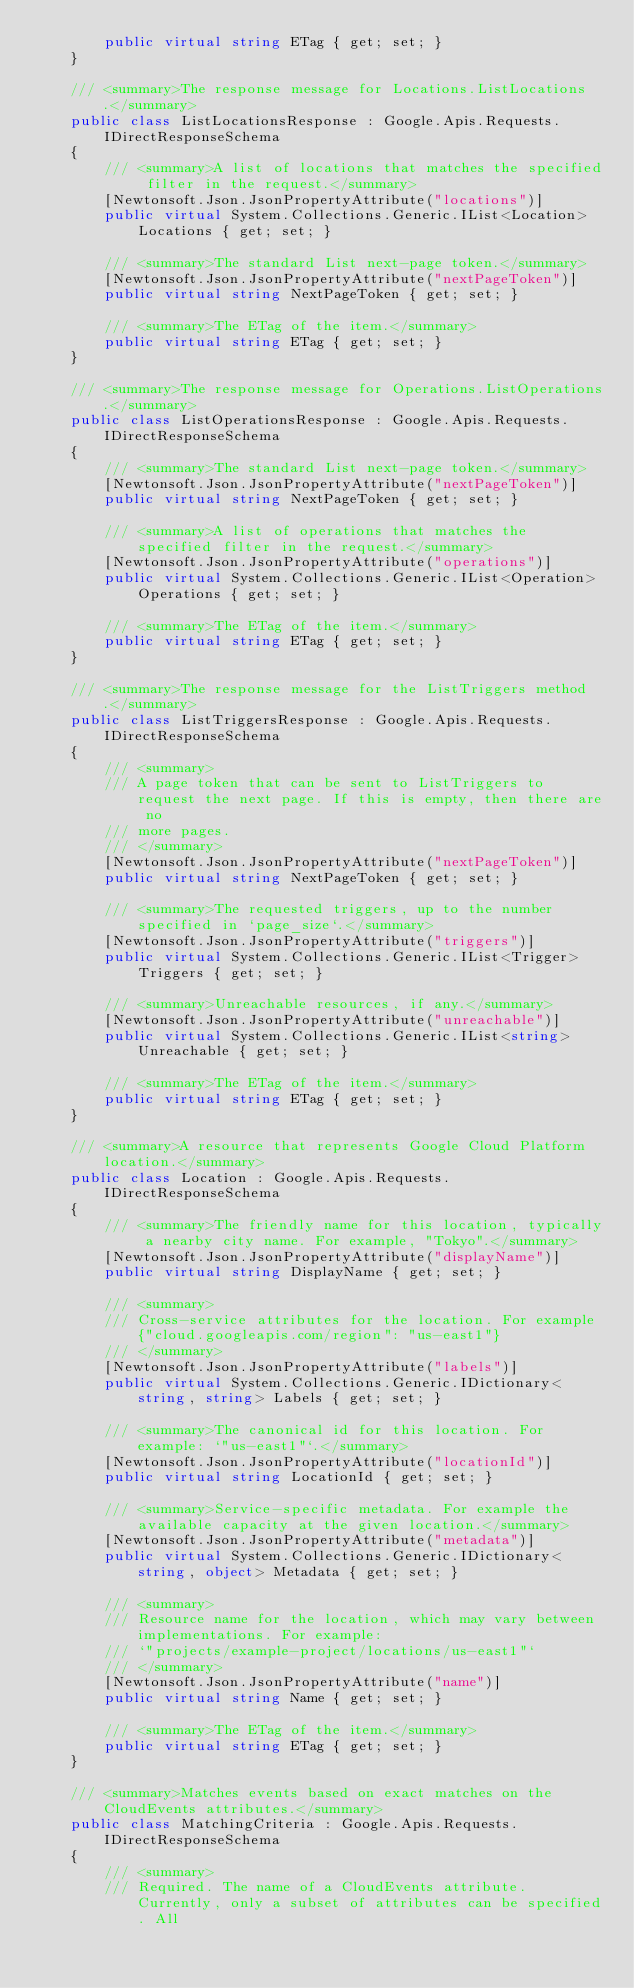<code> <loc_0><loc_0><loc_500><loc_500><_C#_>        public virtual string ETag { get; set; }
    }

    /// <summary>The response message for Locations.ListLocations.</summary>
    public class ListLocationsResponse : Google.Apis.Requests.IDirectResponseSchema
    {
        /// <summary>A list of locations that matches the specified filter in the request.</summary>
        [Newtonsoft.Json.JsonPropertyAttribute("locations")]
        public virtual System.Collections.Generic.IList<Location> Locations { get; set; }

        /// <summary>The standard List next-page token.</summary>
        [Newtonsoft.Json.JsonPropertyAttribute("nextPageToken")]
        public virtual string NextPageToken { get; set; }

        /// <summary>The ETag of the item.</summary>
        public virtual string ETag { get; set; }
    }

    /// <summary>The response message for Operations.ListOperations.</summary>
    public class ListOperationsResponse : Google.Apis.Requests.IDirectResponseSchema
    {
        /// <summary>The standard List next-page token.</summary>
        [Newtonsoft.Json.JsonPropertyAttribute("nextPageToken")]
        public virtual string NextPageToken { get; set; }

        /// <summary>A list of operations that matches the specified filter in the request.</summary>
        [Newtonsoft.Json.JsonPropertyAttribute("operations")]
        public virtual System.Collections.Generic.IList<Operation> Operations { get; set; }

        /// <summary>The ETag of the item.</summary>
        public virtual string ETag { get; set; }
    }

    /// <summary>The response message for the ListTriggers method.</summary>
    public class ListTriggersResponse : Google.Apis.Requests.IDirectResponseSchema
    {
        /// <summary>
        /// A page token that can be sent to ListTriggers to request the next page. If this is empty, then there are no
        /// more pages.
        /// </summary>
        [Newtonsoft.Json.JsonPropertyAttribute("nextPageToken")]
        public virtual string NextPageToken { get; set; }

        /// <summary>The requested triggers, up to the number specified in `page_size`.</summary>
        [Newtonsoft.Json.JsonPropertyAttribute("triggers")]
        public virtual System.Collections.Generic.IList<Trigger> Triggers { get; set; }

        /// <summary>Unreachable resources, if any.</summary>
        [Newtonsoft.Json.JsonPropertyAttribute("unreachable")]
        public virtual System.Collections.Generic.IList<string> Unreachable { get; set; }

        /// <summary>The ETag of the item.</summary>
        public virtual string ETag { get; set; }
    }

    /// <summary>A resource that represents Google Cloud Platform location.</summary>
    public class Location : Google.Apis.Requests.IDirectResponseSchema
    {
        /// <summary>The friendly name for this location, typically a nearby city name. For example, "Tokyo".</summary>
        [Newtonsoft.Json.JsonPropertyAttribute("displayName")]
        public virtual string DisplayName { get; set; }

        /// <summary>
        /// Cross-service attributes for the location. For example {"cloud.googleapis.com/region": "us-east1"}
        /// </summary>
        [Newtonsoft.Json.JsonPropertyAttribute("labels")]
        public virtual System.Collections.Generic.IDictionary<string, string> Labels { get; set; }

        /// <summary>The canonical id for this location. For example: `"us-east1"`.</summary>
        [Newtonsoft.Json.JsonPropertyAttribute("locationId")]
        public virtual string LocationId { get; set; }

        /// <summary>Service-specific metadata. For example the available capacity at the given location.</summary>
        [Newtonsoft.Json.JsonPropertyAttribute("metadata")]
        public virtual System.Collections.Generic.IDictionary<string, object> Metadata { get; set; }

        /// <summary>
        /// Resource name for the location, which may vary between implementations. For example:
        /// `"projects/example-project/locations/us-east1"`
        /// </summary>
        [Newtonsoft.Json.JsonPropertyAttribute("name")]
        public virtual string Name { get; set; }

        /// <summary>The ETag of the item.</summary>
        public virtual string ETag { get; set; }
    }

    /// <summary>Matches events based on exact matches on the CloudEvents attributes.</summary>
    public class MatchingCriteria : Google.Apis.Requests.IDirectResponseSchema
    {
        /// <summary>
        /// Required. The name of a CloudEvents attribute. Currently, only a subset of attributes can be specified. All</code> 